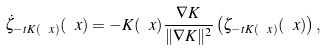Convert formula to latex. <formula><loc_0><loc_0><loc_500><loc_500>\dot { \zeta } _ { - t K ( \ x ) } ( \ x ) = - K ( \ x ) \frac { \nabla K } { \| \nabla K \| ^ { 2 } } \left ( \zeta _ { - t K ( \ x ) } ( \ x ) \right ) ,</formula> 